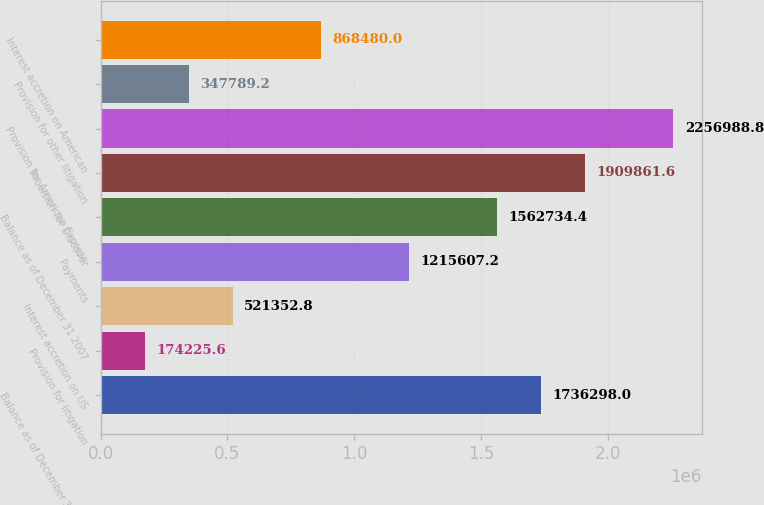Convert chart to OTSL. <chart><loc_0><loc_0><loc_500><loc_500><bar_chart><fcel>Balance as of December 31 2006<fcel>Provision for litigation<fcel>Interest accretion on US<fcel>Payments<fcel>Balance as of December 31 2007<fcel>Provision for Discover<fcel>Provision for American Express<fcel>Provision for other litigation<fcel>Interest accretion on American<nl><fcel>1.7363e+06<fcel>174226<fcel>521353<fcel>1.21561e+06<fcel>1.56273e+06<fcel>1.90986e+06<fcel>2.25699e+06<fcel>347789<fcel>868480<nl></chart> 